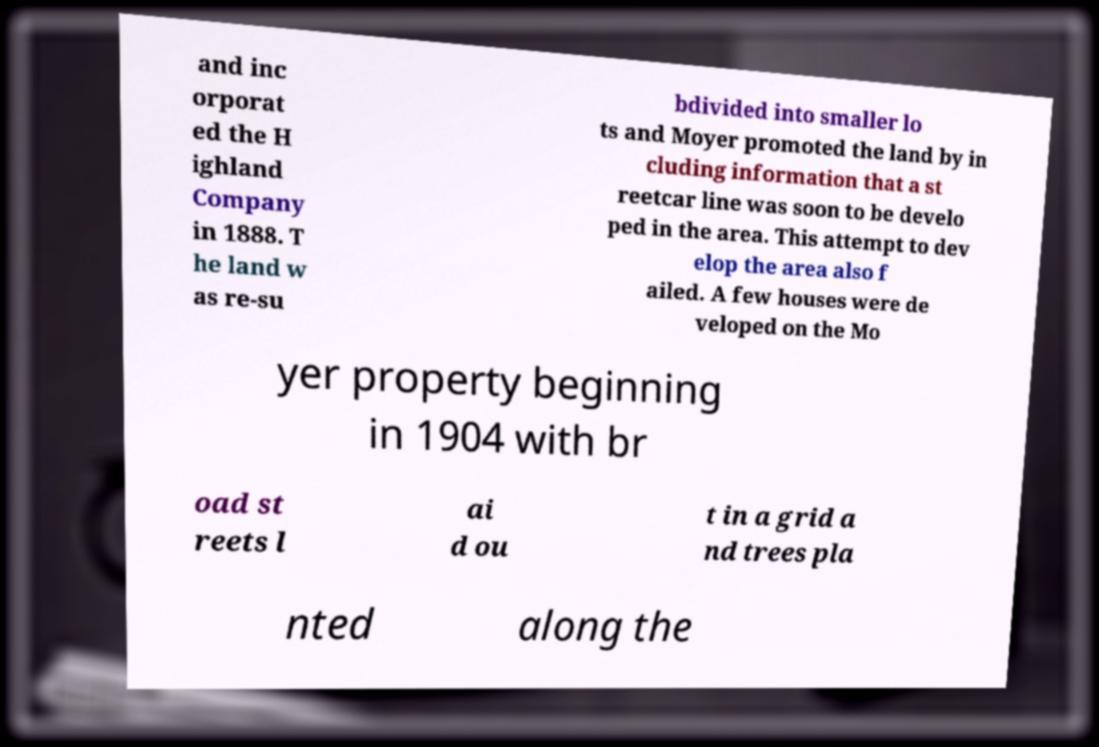What messages or text are displayed in this image? I need them in a readable, typed format. and inc orporat ed the H ighland Company in 1888. T he land w as re-su bdivided into smaller lo ts and Moyer promoted the land by in cluding information that a st reetcar line was soon to be develo ped in the area. This attempt to dev elop the area also f ailed. A few houses were de veloped on the Mo yer property beginning in 1904 with br oad st reets l ai d ou t in a grid a nd trees pla nted along the 